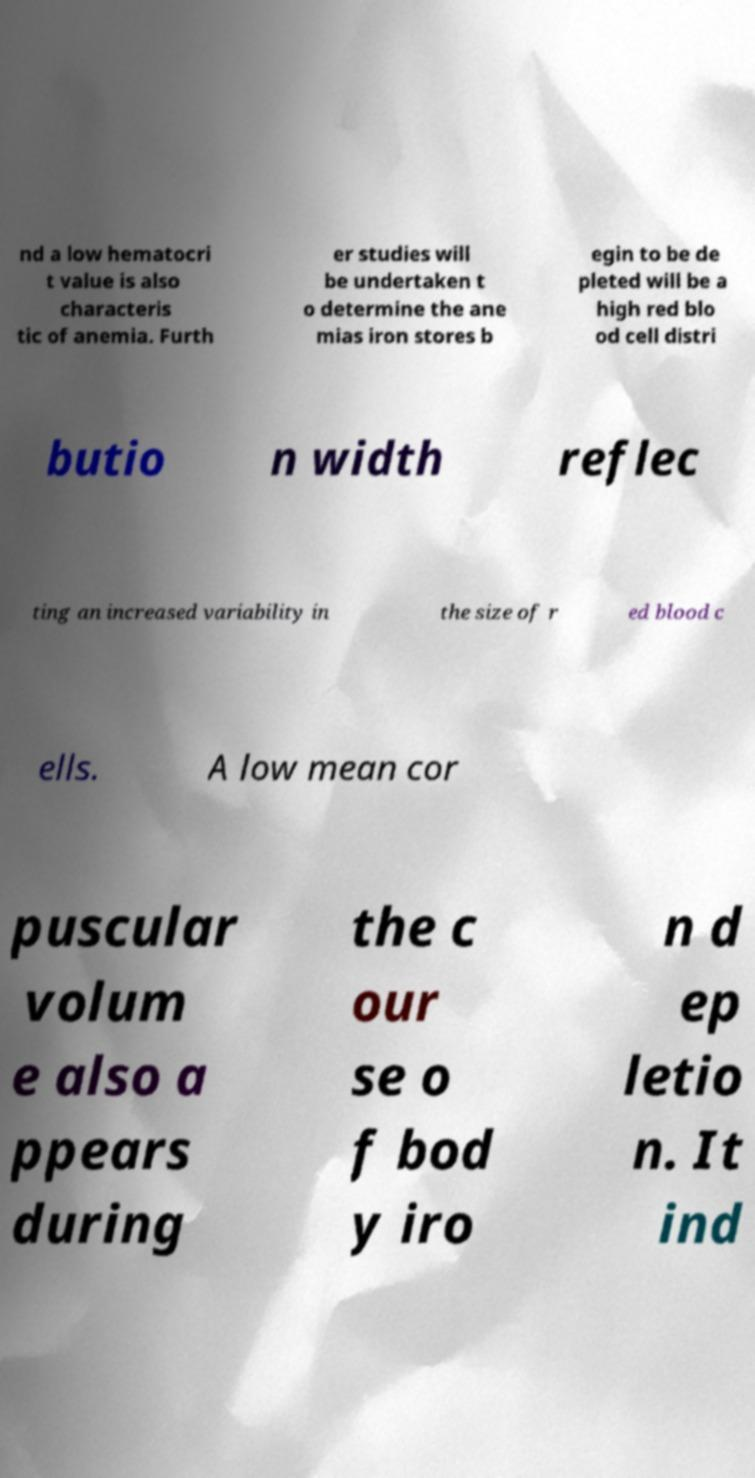There's text embedded in this image that I need extracted. Can you transcribe it verbatim? nd a low hematocri t value is also characteris tic of anemia. Furth er studies will be undertaken t o determine the ane mias iron stores b egin to be de pleted will be a high red blo od cell distri butio n width reflec ting an increased variability in the size of r ed blood c ells. A low mean cor puscular volum e also a ppears during the c our se o f bod y iro n d ep letio n. It ind 